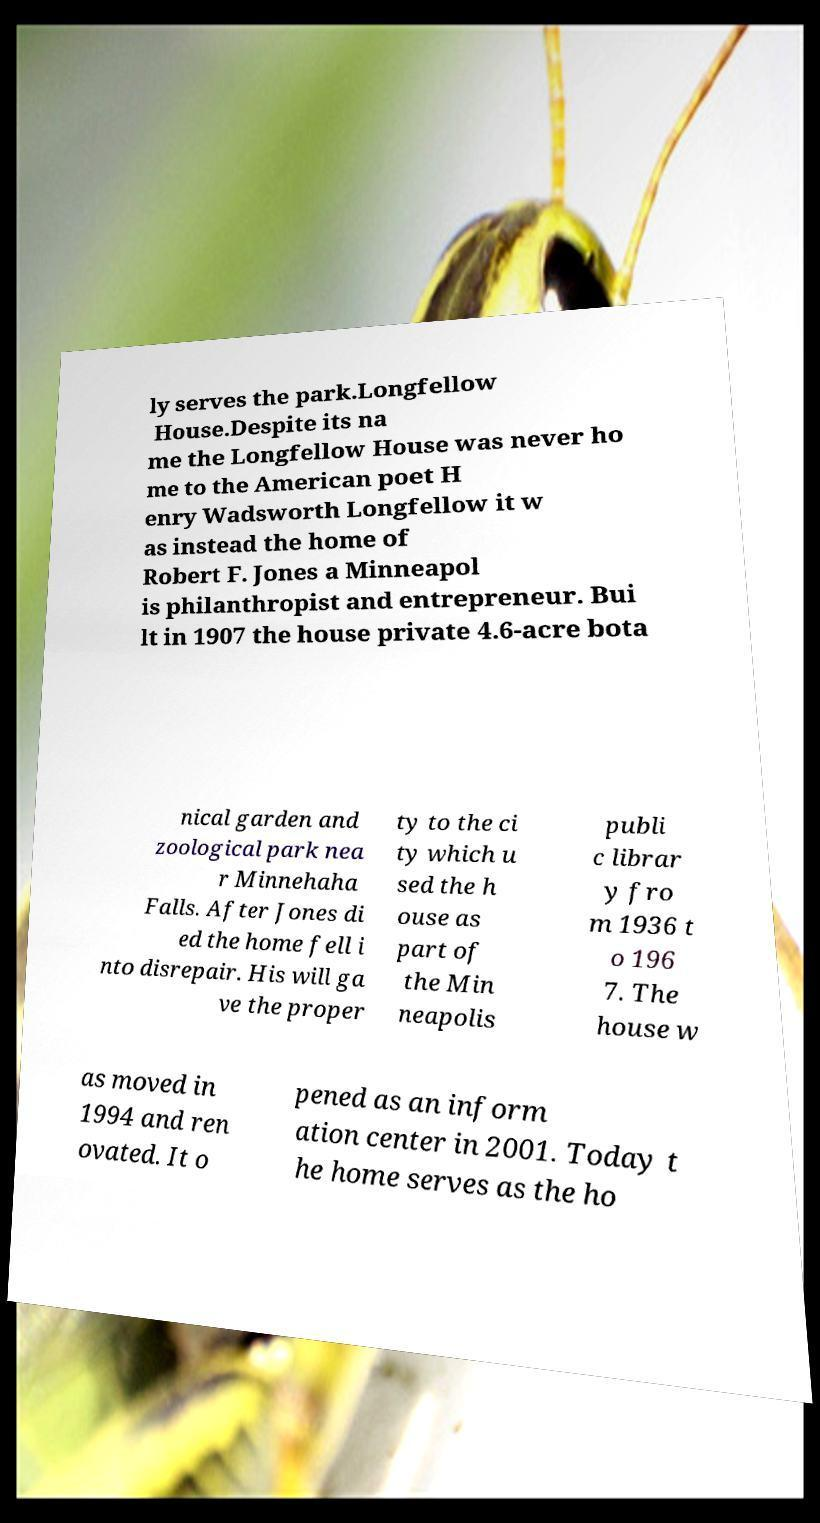Could you extract and type out the text from this image? ly serves the park.Longfellow House.Despite its na me the Longfellow House was never ho me to the American poet H enry Wadsworth Longfellow it w as instead the home of Robert F. Jones a Minneapol is philanthropist and entrepreneur. Bui lt in 1907 the house private 4.6-acre bota nical garden and zoological park nea r Minnehaha Falls. After Jones di ed the home fell i nto disrepair. His will ga ve the proper ty to the ci ty which u sed the h ouse as part of the Min neapolis publi c librar y fro m 1936 t o 196 7. The house w as moved in 1994 and ren ovated. It o pened as an inform ation center in 2001. Today t he home serves as the ho 